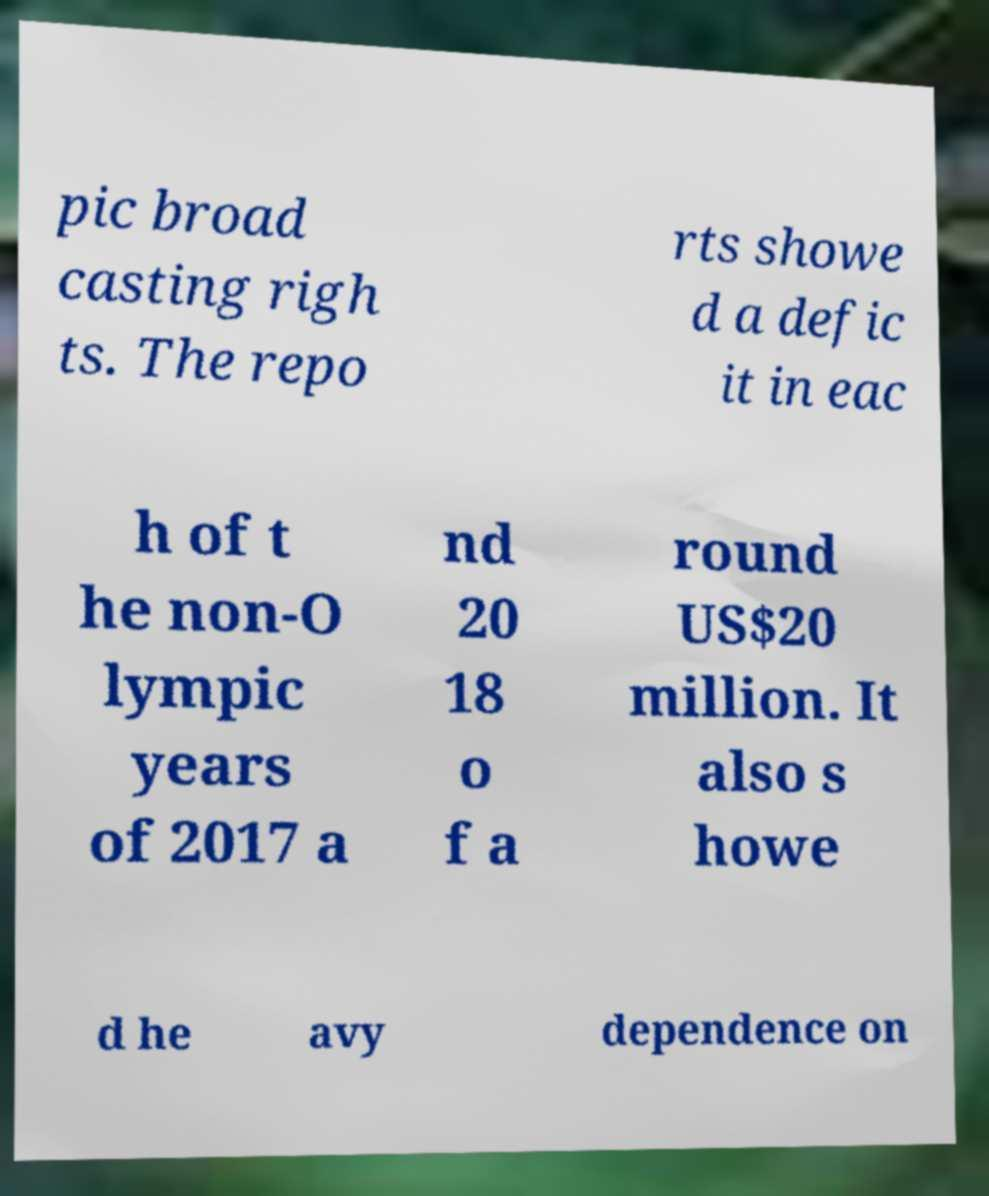For documentation purposes, I need the text within this image transcribed. Could you provide that? pic broad casting righ ts. The repo rts showe d a defic it in eac h of t he non-O lympic years of 2017 a nd 20 18 o f a round US$20 million. It also s howe d he avy dependence on 